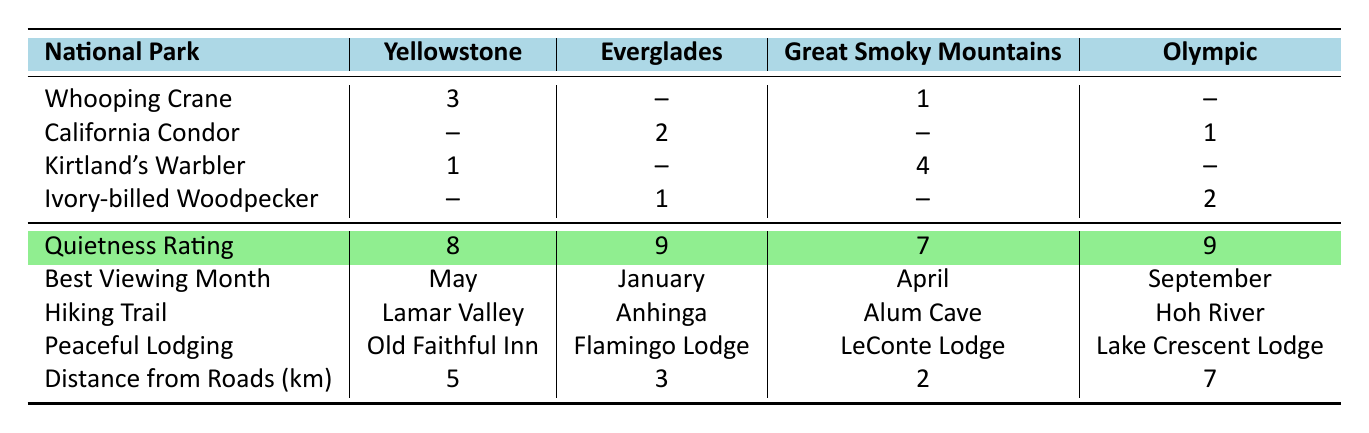What is the quietness rating for Everglades National Park? The table indicates that the quietness rating for Everglades National Park is listed directly under that park, which shows a rating of 9.
Answer: 9 Which park has the most sightings of Kirtland's Warbler? By examining the table, Kirtland's Warbler has 4 sightings in Great Smoky Mountains National Park, which is the highest number listed for that species.
Answer: Great Smoky Mountains National Park How many total rare species sightings are reported across all national parks? To find the total sightings, add all sightings from the table: 3 (Yellowstone) + 0 (Everglades) + 1 (Great Smoky) + 0 (Olympic) for Whooping Crane; then, 0 + 2 + 0 + 1 for California Condor; then, 1 + 0 + 4 + 0 for Kirtland's Warbler; and finally, 0 + 1 + 0 + 2 for Ivory-billed Woodpecker. The total is 3 + 3 + 5 + 3 = 14 sightings.
Answer: 14 Which national park offers the nearest peaceful lodging? The nearest peaceful lodging is evaluated by the distance from roads along with quietness. Anhinga Trail in Everglades National Park has the least distance from roads (3 km) and a high quietness rating (9), making it the best option.
Answer: Everglades National Park Which species has the fewest sightings overall? To determine the species with the fewest sightings, count the sightings: Whooping Crane has 3, California Condor has 3, Kirtland's Warbler has 5, and Ivory-billed Woodpecker has 3. The Whooping Crane, California Condor, and Ivory-billed Woodpecker all have the lowest at 3 sightings.
Answer: Whooping Crane, California Condor, Ivory-billed Woodpecker In which month is the best viewing time for California Condor? Referring to the table, the best viewing month for California Condor is listed as January, which is under the corresponding column for that species.
Answer: January What is the average quietness rating of the national parks in the table? To calculate the average, add the quietness ratings: 8 (Yellowstone) + 9 (Everglades) + 7 (Great Smoky) + 9 (Olympic) = 33 and divide by 4 (the number of parks): 33 / 4 = 8.25.
Answer: 8.25 Is there a national park with a distance from roads greater than 5 km? By checking the table for distances from roads, only Olympic National Park shows a distance of 7 km, which is greater than 5 km, confirming the truth of the statement.
Answer: Yes Which park has the highest number of rare species sightings in total? Calculate total rare sightings for each park: Yellowstone (3+0+1+0=4), Everglades (0+2+0+1=3), Great Smoky (1+0+4+0=5), Olympic (0+1+0+2=3). Great Smoky Mountains National Park has the highest total sightings at 5.
Answer: Great Smoky Mountains National Park What hiking trail is associated with the best quietness rating? The table shows that both Everglades and Olympic National Parks have the highest quietness rating of 9. The hiking trail for Everglades is Anhinga Trail while for Olympic is Hoh River Trail. Thus, either trail is associated with the best quietness rating.
Answer: Anhinga Trail or Hoh River Trail 